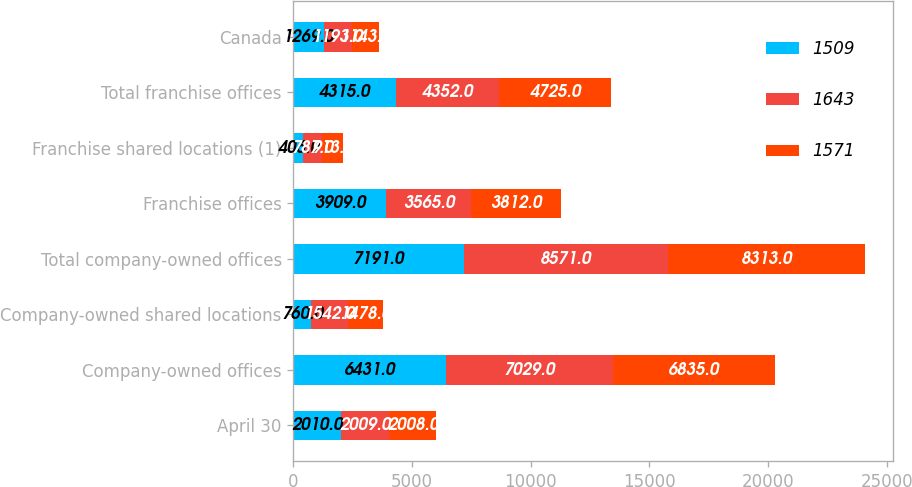<chart> <loc_0><loc_0><loc_500><loc_500><stacked_bar_chart><ecel><fcel>April 30<fcel>Company-owned offices<fcel>Company-owned shared locations<fcel>Total company-owned offices<fcel>Franchise offices<fcel>Franchise shared locations (1)<fcel>Total franchise offices<fcel>Canada<nl><fcel>1509<fcel>2010<fcel>6431<fcel>760<fcel>7191<fcel>3909<fcel>406<fcel>4315<fcel>1269<nl><fcel>1643<fcel>2009<fcel>7029<fcel>1542<fcel>8571<fcel>3565<fcel>787<fcel>4352<fcel>1193<nl><fcel>1571<fcel>2008<fcel>6835<fcel>1478<fcel>8313<fcel>3812<fcel>913<fcel>4725<fcel>1143<nl></chart> 